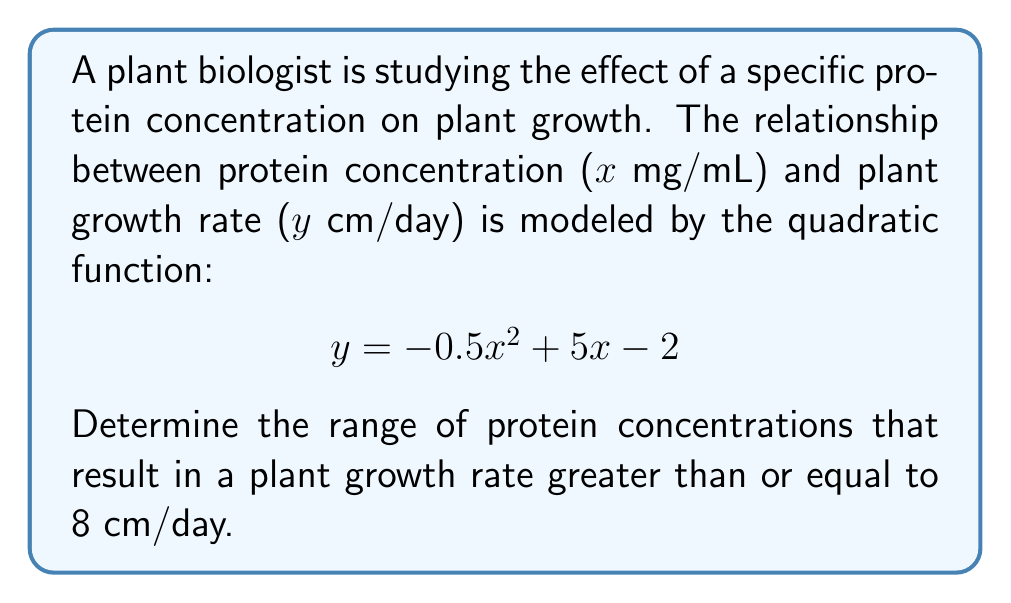What is the answer to this math problem? 1) To find the range of protein concentrations, we need to solve the inequality:

   $$ -0.5x^2 + 5x - 2 \geq 8 $$

2) Rearrange the inequality:
   $$ -0.5x^2 + 5x - 10 \geq 0 $$

3) This is a quadratic inequality. To solve it, we first find the roots of the corresponding quadratic equation:
   $$ -0.5x^2 + 5x - 10 = 0 $$

4) Use the quadratic formula: $x = \frac{-b \pm \sqrt{b^2 - 4ac}}{2a}$
   Where $a = -0.5$, $b = 5$, and $c = -10$

5) Substituting these values:
   $$ x = \frac{-5 \pm \sqrt{5^2 - 4(-0.5)(-10)}}{2(-0.5)} $$
   $$ x = \frac{-5 \pm \sqrt{25 - 20}}{-1} $$
   $$ x = \frac{-5 \pm \sqrt{5}}{-1} $$

6) Solving:
   $$ x_1 = \frac{-5 + \sqrt{5}}{-1} \approx 1.76 $$
   $$ x_2 = \frac{-5 - \sqrt{5}}{-1} \approx 8.24 $$

7) The parabola opens downward (a < 0), so the inequality is satisfied between these two roots.

Therefore, the range of protein concentrations that result in a plant growth rate greater than or equal to 8 cm/day is approximately 1.76 ≤ x ≤ 8.24 mg/mL.
Answer: $1.76 \leq x \leq 8.24$ mg/mL 